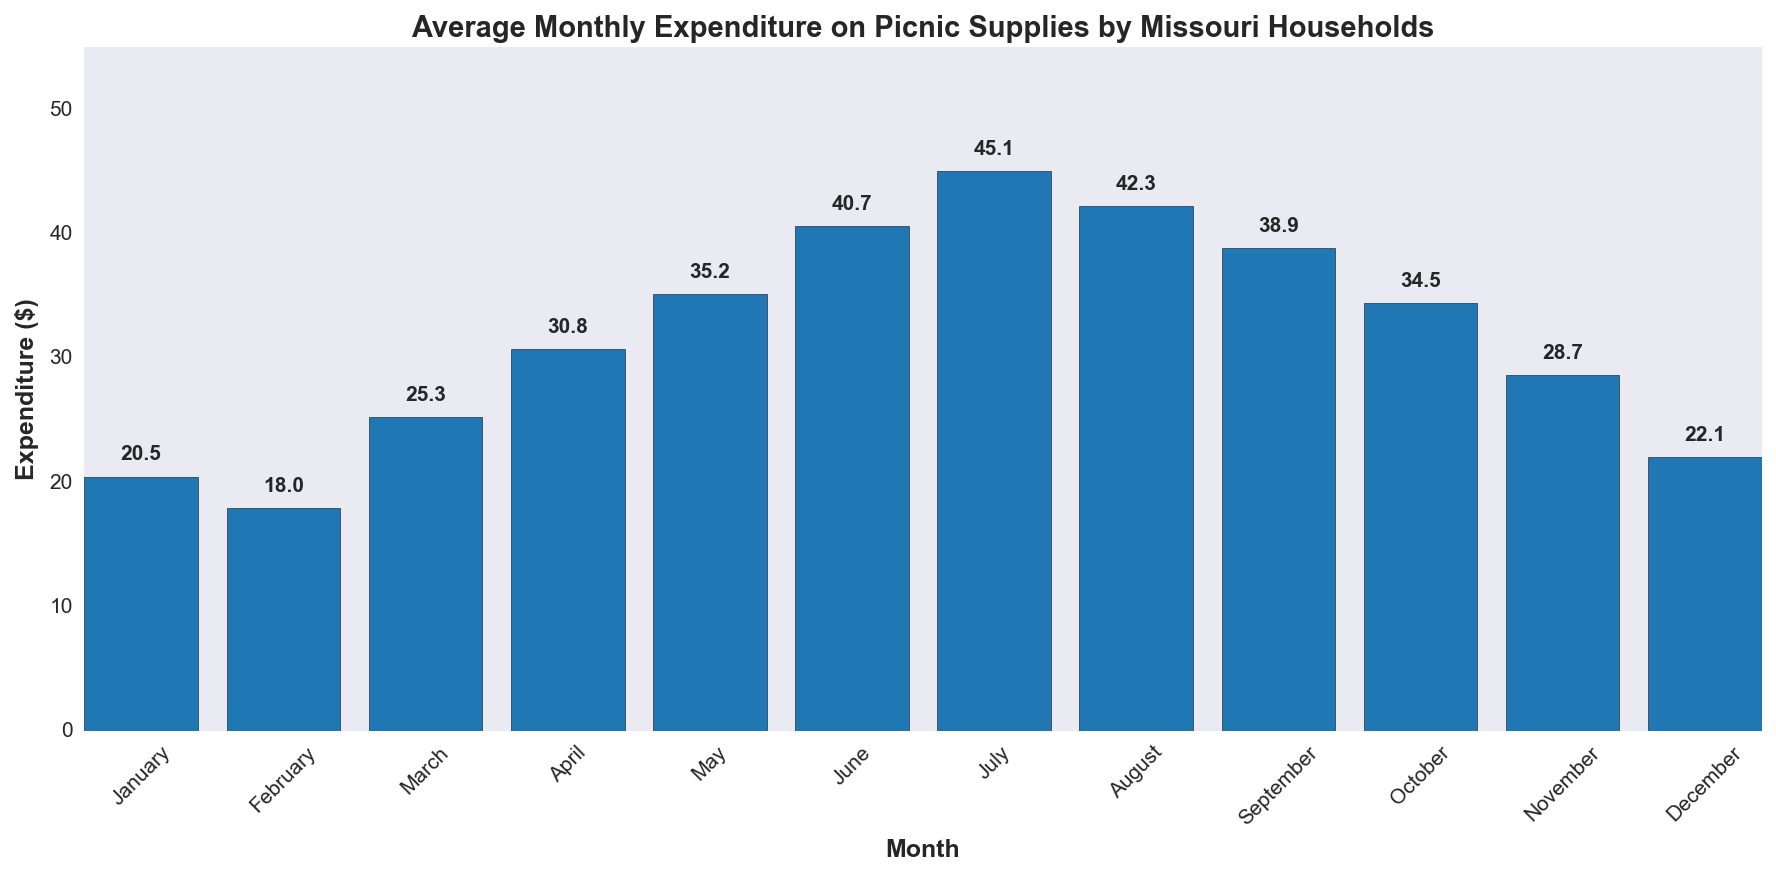Which month has the highest average expenditure on picnic supplies? The bar chart shows the average expenditure for each month. The tallest bar represents the month with the highest expenditure. July has the highest bar.
Answer: July Which month has the lowest average expenditure on picnic supplies? The shortest bar corresponds to the lowest average expenditure. The bar for February is the shortest.
Answer: February How much more is the average expenditure in June compared to February? The average expenditure in June is $40.7 and in February is $18. The difference is $40.7 - $18.
Answer: $22.7 What is the total average expenditure from April to June? Sum the average expenditures for April, May, and June: $30.8 + $35.2 + $40.7. This equals $106.7.
Answer: $106.7 Which months have expenditures higher than $30? Visually inspect the chart and identify months with bars higher than $30. These months are April, May, June, July, August, and September.
Answer: April, May, June, July, August, September What is the average expenditure for the first quarter (January to March)? Sum the expenditures for January, February, and March and divide by 3: $(20.5 + 18 + 25.3)/3$. This equals approximately $21.27.
Answer: $21.27 By how much does average expenditure increase from March to July? The average expenditure in March is $25.3 and in July is $45.1. The increase is $45.1 - $25.3.
Answer: $19.8 Which quarter (3-month period) has the highest total average expenditure? Calculate the sum for each quarter and compare:
Q1: $(20.5+18+25.3)=63.8$, 
Q2: $(30.8+35.2+40.7)=106.7$, 
Q3: $(45.1+42.3+38.9)=126.3$,
Q4: $(34.5+28.7+22.1)=85.3$. Q3 has the highest total.
Answer: Q3 What's the difference in expenditure between the month with the highest expenditure and the month with the lowest expenditure? July has the highest expenditure ($45.1) and February has the lowest ($18). The difference is $45.1 - $18.
Answer: $27.1 